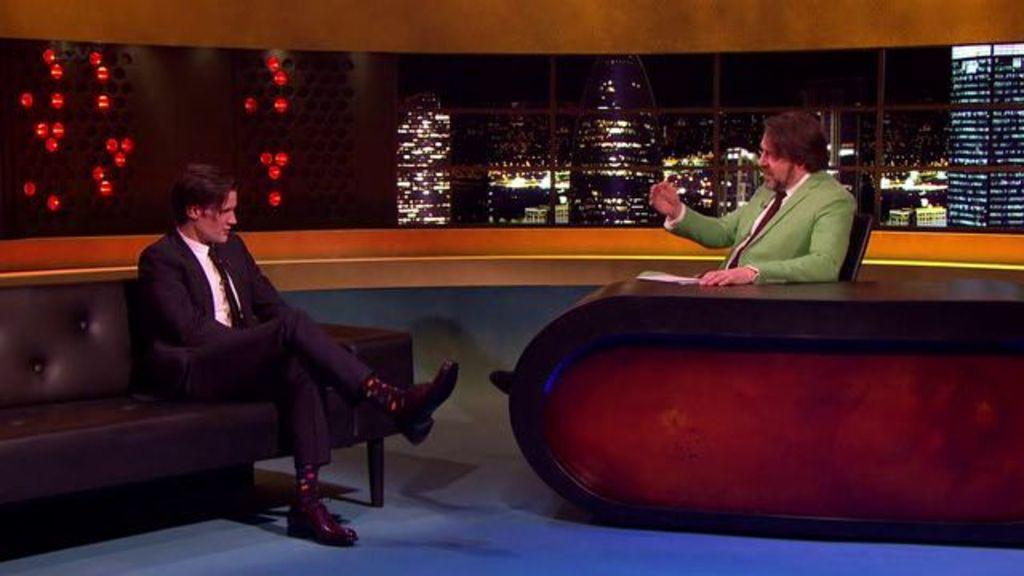What is the man in the image doing? The man is sitting in a chair at a table and questioning another person. Who is the man talking to? The man is questioning another person, but the image does not show the other person. Is there anyone else in the image besides the man in the chair? Yes, there is another man sitting beside the first man. Where is the second man sitting? The second man is sitting in a sofa. What type of mountain can be seen in the background of the image? There is no mountain visible in the image; it is an indoor setting with a man sitting in a chair at a table and another man sitting in a sofa. 